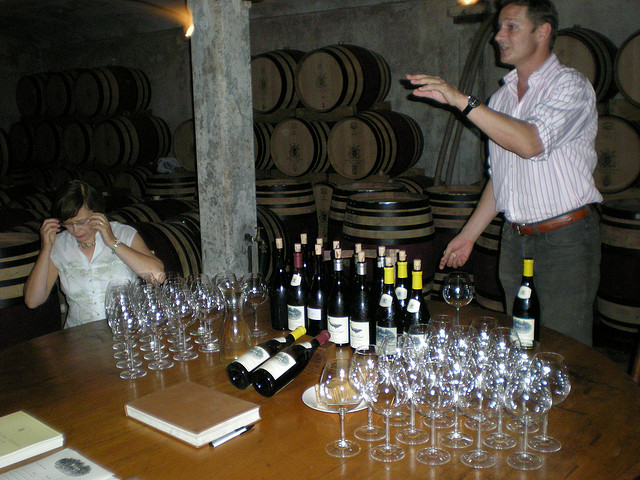Can you tell what type of wine might be predominantly produced at this winery? From the assortment of bottles shown, there appears to be a variety of both red and white wines, suggesting that the winery produces a diverse range of wines. The presence of aged oak barrels indicates that they likely focus on wines that benefit from barrel aging, such as Chardonnay or Pinot Noir, depending on whether they emphasize red or white wines. 